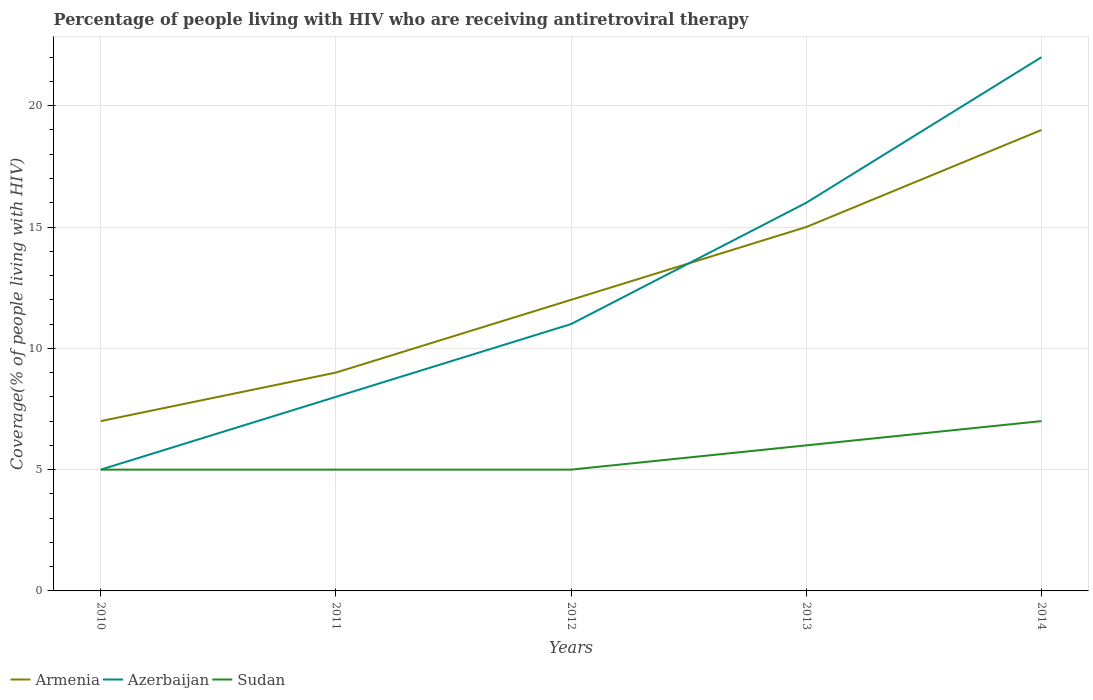Is the number of lines equal to the number of legend labels?
Give a very brief answer. Yes. Across all years, what is the maximum percentage of the HIV infected people who are receiving antiretroviral therapy in Armenia?
Keep it short and to the point. 7. In which year was the percentage of the HIV infected people who are receiving antiretroviral therapy in Sudan maximum?
Provide a short and direct response. 2010. What is the total percentage of the HIV infected people who are receiving antiretroviral therapy in Azerbaijan in the graph?
Ensure brevity in your answer.  -17. What is the difference between the highest and the second highest percentage of the HIV infected people who are receiving antiretroviral therapy in Sudan?
Provide a short and direct response. 2. What is the difference between the highest and the lowest percentage of the HIV infected people who are receiving antiretroviral therapy in Azerbaijan?
Keep it short and to the point. 2. Is the percentage of the HIV infected people who are receiving antiretroviral therapy in Sudan strictly greater than the percentage of the HIV infected people who are receiving antiretroviral therapy in Azerbaijan over the years?
Offer a terse response. No. How many years are there in the graph?
Give a very brief answer. 5. Are the values on the major ticks of Y-axis written in scientific E-notation?
Your answer should be compact. No. Does the graph contain any zero values?
Ensure brevity in your answer.  No. Does the graph contain grids?
Provide a short and direct response. Yes. Where does the legend appear in the graph?
Your response must be concise. Bottom left. What is the title of the graph?
Provide a succinct answer. Percentage of people living with HIV who are receiving antiretroviral therapy. What is the label or title of the X-axis?
Your response must be concise. Years. What is the label or title of the Y-axis?
Your response must be concise. Coverage(% of people living with HIV). What is the Coverage(% of people living with HIV) in Armenia in 2010?
Ensure brevity in your answer.  7. What is the Coverage(% of people living with HIV) of Armenia in 2011?
Provide a succinct answer. 9. What is the Coverage(% of people living with HIV) of Armenia in 2012?
Provide a succinct answer. 12. What is the Coverage(% of people living with HIV) in Azerbaijan in 2012?
Ensure brevity in your answer.  11. What is the Coverage(% of people living with HIV) of Sudan in 2012?
Keep it short and to the point. 5. What is the Coverage(% of people living with HIV) of Azerbaijan in 2013?
Your answer should be compact. 16. What is the Coverage(% of people living with HIV) in Sudan in 2013?
Your response must be concise. 6. What is the total Coverage(% of people living with HIV) of Armenia in the graph?
Give a very brief answer. 62. What is the total Coverage(% of people living with HIV) of Azerbaijan in the graph?
Your answer should be compact. 62. What is the total Coverage(% of people living with HIV) in Sudan in the graph?
Provide a short and direct response. 28. What is the difference between the Coverage(% of people living with HIV) in Azerbaijan in 2010 and that in 2011?
Offer a terse response. -3. What is the difference between the Coverage(% of people living with HIV) in Armenia in 2010 and that in 2012?
Make the answer very short. -5. What is the difference between the Coverage(% of people living with HIV) in Azerbaijan in 2010 and that in 2012?
Keep it short and to the point. -6. What is the difference between the Coverage(% of people living with HIV) in Sudan in 2010 and that in 2012?
Keep it short and to the point. 0. What is the difference between the Coverage(% of people living with HIV) in Azerbaijan in 2010 and that in 2013?
Make the answer very short. -11. What is the difference between the Coverage(% of people living with HIV) of Azerbaijan in 2011 and that in 2012?
Offer a terse response. -3. What is the difference between the Coverage(% of people living with HIV) of Sudan in 2011 and that in 2012?
Provide a succinct answer. 0. What is the difference between the Coverage(% of people living with HIV) of Sudan in 2011 and that in 2013?
Keep it short and to the point. -1. What is the difference between the Coverage(% of people living with HIV) in Sudan in 2011 and that in 2014?
Provide a succinct answer. -2. What is the difference between the Coverage(% of people living with HIV) of Armenia in 2012 and that in 2013?
Make the answer very short. -3. What is the difference between the Coverage(% of people living with HIV) of Armenia in 2012 and that in 2014?
Your response must be concise. -7. What is the difference between the Coverage(% of people living with HIV) of Azerbaijan in 2012 and that in 2014?
Provide a succinct answer. -11. What is the difference between the Coverage(% of people living with HIV) in Azerbaijan in 2013 and that in 2014?
Offer a very short reply. -6. What is the difference between the Coverage(% of people living with HIV) of Azerbaijan in 2010 and the Coverage(% of people living with HIV) of Sudan in 2011?
Provide a succinct answer. 0. What is the difference between the Coverage(% of people living with HIV) of Armenia in 2010 and the Coverage(% of people living with HIV) of Azerbaijan in 2013?
Give a very brief answer. -9. What is the difference between the Coverage(% of people living with HIV) in Armenia in 2010 and the Coverage(% of people living with HIV) in Sudan in 2013?
Your answer should be compact. 1. What is the difference between the Coverage(% of people living with HIV) in Armenia in 2010 and the Coverage(% of people living with HIV) in Sudan in 2014?
Provide a short and direct response. 0. What is the difference between the Coverage(% of people living with HIV) in Armenia in 2011 and the Coverage(% of people living with HIV) in Azerbaijan in 2012?
Your response must be concise. -2. What is the difference between the Coverage(% of people living with HIV) in Armenia in 2011 and the Coverage(% of people living with HIV) in Sudan in 2012?
Provide a short and direct response. 4. What is the difference between the Coverage(% of people living with HIV) in Azerbaijan in 2011 and the Coverage(% of people living with HIV) in Sudan in 2012?
Make the answer very short. 3. What is the difference between the Coverage(% of people living with HIV) of Armenia in 2011 and the Coverage(% of people living with HIV) of Azerbaijan in 2013?
Give a very brief answer. -7. What is the difference between the Coverage(% of people living with HIV) in Armenia in 2011 and the Coverage(% of people living with HIV) in Sudan in 2014?
Ensure brevity in your answer.  2. What is the difference between the Coverage(% of people living with HIV) of Azerbaijan in 2011 and the Coverage(% of people living with HIV) of Sudan in 2014?
Offer a terse response. 1. What is the difference between the Coverage(% of people living with HIV) of Armenia in 2013 and the Coverage(% of people living with HIV) of Sudan in 2014?
Offer a very short reply. 8. What is the difference between the Coverage(% of people living with HIV) of Azerbaijan in 2013 and the Coverage(% of people living with HIV) of Sudan in 2014?
Your response must be concise. 9. What is the average Coverage(% of people living with HIV) of Armenia per year?
Provide a short and direct response. 12.4. In the year 2010, what is the difference between the Coverage(% of people living with HIV) in Armenia and Coverage(% of people living with HIV) in Azerbaijan?
Your answer should be very brief. 2. In the year 2010, what is the difference between the Coverage(% of people living with HIV) of Azerbaijan and Coverage(% of people living with HIV) of Sudan?
Your response must be concise. 0. In the year 2011, what is the difference between the Coverage(% of people living with HIV) of Armenia and Coverage(% of people living with HIV) of Azerbaijan?
Offer a terse response. 1. In the year 2011, what is the difference between the Coverage(% of people living with HIV) in Armenia and Coverage(% of people living with HIV) in Sudan?
Provide a short and direct response. 4. In the year 2011, what is the difference between the Coverage(% of people living with HIV) in Azerbaijan and Coverage(% of people living with HIV) in Sudan?
Keep it short and to the point. 3. In the year 2012, what is the difference between the Coverage(% of people living with HIV) in Armenia and Coverage(% of people living with HIV) in Azerbaijan?
Make the answer very short. 1. In the year 2012, what is the difference between the Coverage(% of people living with HIV) of Armenia and Coverage(% of people living with HIV) of Sudan?
Your answer should be very brief. 7. In the year 2014, what is the difference between the Coverage(% of people living with HIV) of Armenia and Coverage(% of people living with HIV) of Azerbaijan?
Provide a short and direct response. -3. In the year 2014, what is the difference between the Coverage(% of people living with HIV) in Armenia and Coverage(% of people living with HIV) in Sudan?
Provide a succinct answer. 12. In the year 2014, what is the difference between the Coverage(% of people living with HIV) of Azerbaijan and Coverage(% of people living with HIV) of Sudan?
Offer a terse response. 15. What is the ratio of the Coverage(% of people living with HIV) in Armenia in 2010 to that in 2012?
Keep it short and to the point. 0.58. What is the ratio of the Coverage(% of people living with HIV) in Azerbaijan in 2010 to that in 2012?
Make the answer very short. 0.45. What is the ratio of the Coverage(% of people living with HIV) in Sudan in 2010 to that in 2012?
Your answer should be compact. 1. What is the ratio of the Coverage(% of people living with HIV) of Armenia in 2010 to that in 2013?
Offer a terse response. 0.47. What is the ratio of the Coverage(% of people living with HIV) in Azerbaijan in 2010 to that in 2013?
Provide a short and direct response. 0.31. What is the ratio of the Coverage(% of people living with HIV) of Sudan in 2010 to that in 2013?
Offer a terse response. 0.83. What is the ratio of the Coverage(% of people living with HIV) in Armenia in 2010 to that in 2014?
Provide a short and direct response. 0.37. What is the ratio of the Coverage(% of people living with HIV) in Azerbaijan in 2010 to that in 2014?
Give a very brief answer. 0.23. What is the ratio of the Coverage(% of people living with HIV) of Armenia in 2011 to that in 2012?
Provide a short and direct response. 0.75. What is the ratio of the Coverage(% of people living with HIV) in Azerbaijan in 2011 to that in 2012?
Your answer should be compact. 0.73. What is the ratio of the Coverage(% of people living with HIV) of Sudan in 2011 to that in 2012?
Keep it short and to the point. 1. What is the ratio of the Coverage(% of people living with HIV) in Armenia in 2011 to that in 2014?
Offer a terse response. 0.47. What is the ratio of the Coverage(% of people living with HIV) of Azerbaijan in 2011 to that in 2014?
Make the answer very short. 0.36. What is the ratio of the Coverage(% of people living with HIV) of Sudan in 2011 to that in 2014?
Your answer should be very brief. 0.71. What is the ratio of the Coverage(% of people living with HIV) of Azerbaijan in 2012 to that in 2013?
Your answer should be very brief. 0.69. What is the ratio of the Coverage(% of people living with HIV) in Sudan in 2012 to that in 2013?
Ensure brevity in your answer.  0.83. What is the ratio of the Coverage(% of people living with HIV) of Armenia in 2012 to that in 2014?
Make the answer very short. 0.63. What is the ratio of the Coverage(% of people living with HIV) in Azerbaijan in 2012 to that in 2014?
Offer a terse response. 0.5. What is the ratio of the Coverage(% of people living with HIV) of Sudan in 2012 to that in 2014?
Ensure brevity in your answer.  0.71. What is the ratio of the Coverage(% of people living with HIV) of Armenia in 2013 to that in 2014?
Your answer should be very brief. 0.79. What is the ratio of the Coverage(% of people living with HIV) of Azerbaijan in 2013 to that in 2014?
Make the answer very short. 0.73. What is the ratio of the Coverage(% of people living with HIV) in Sudan in 2013 to that in 2014?
Provide a succinct answer. 0.86. What is the difference between the highest and the second highest Coverage(% of people living with HIV) in Azerbaijan?
Your response must be concise. 6. What is the difference between the highest and the second highest Coverage(% of people living with HIV) in Sudan?
Your response must be concise. 1. What is the difference between the highest and the lowest Coverage(% of people living with HIV) in Armenia?
Offer a terse response. 12. What is the difference between the highest and the lowest Coverage(% of people living with HIV) of Azerbaijan?
Offer a very short reply. 17. What is the difference between the highest and the lowest Coverage(% of people living with HIV) in Sudan?
Your response must be concise. 2. 